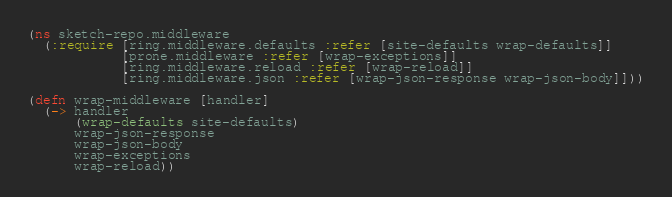<code> <loc_0><loc_0><loc_500><loc_500><_Clojure_>(ns sketch-repo.middleware
  (:require [ring.middleware.defaults :refer [site-defaults wrap-defaults]]
            [prone.middleware :refer [wrap-exceptions]]
            [ring.middleware.reload :refer [wrap-reload]]
            [ring.middleware.json :refer [wrap-json-response wrap-json-body]]))

(defn wrap-middleware [handler]
  (-> handler
      (wrap-defaults site-defaults)
      wrap-json-response
      wrap-json-body
      wrap-exceptions
      wrap-reload))
</code> 